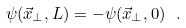<formula> <loc_0><loc_0><loc_500><loc_500>\psi ( \vec { x } _ { \bot } , L ) = - \psi ( \vec { x } _ { \bot } , 0 ) \ .</formula> 